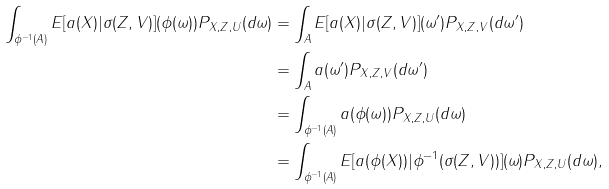Convert formula to latex. <formula><loc_0><loc_0><loc_500><loc_500>\int _ { \phi ^ { - 1 } ( A ) } E [ a ( X ) | \sigma ( Z , V ) ] ( \phi ( \omega ) ) P _ { X , Z , U } ( d \omega ) & = \int _ { A } E [ a ( X ) | \sigma ( Z , V ) ] ( \omega ^ { \prime } ) P _ { X , Z , V } ( d \omega ^ { \prime } ) \\ & = \int _ { A } a ( \omega ^ { \prime } ) P _ { X , Z , V } ( d \omega ^ { \prime } ) \\ & = \int _ { \phi ^ { - 1 } ( A ) } a ( \phi ( \omega ) ) P _ { X , Z , U } ( d \omega ) \\ & = \int _ { \phi ^ { - 1 } ( A ) } E [ a ( \phi ( X ) ) | \phi ^ { - 1 } ( \sigma ( Z , V ) ) ] ( \omega ) P _ { X , Z , U } ( d \omega ) ,</formula> 